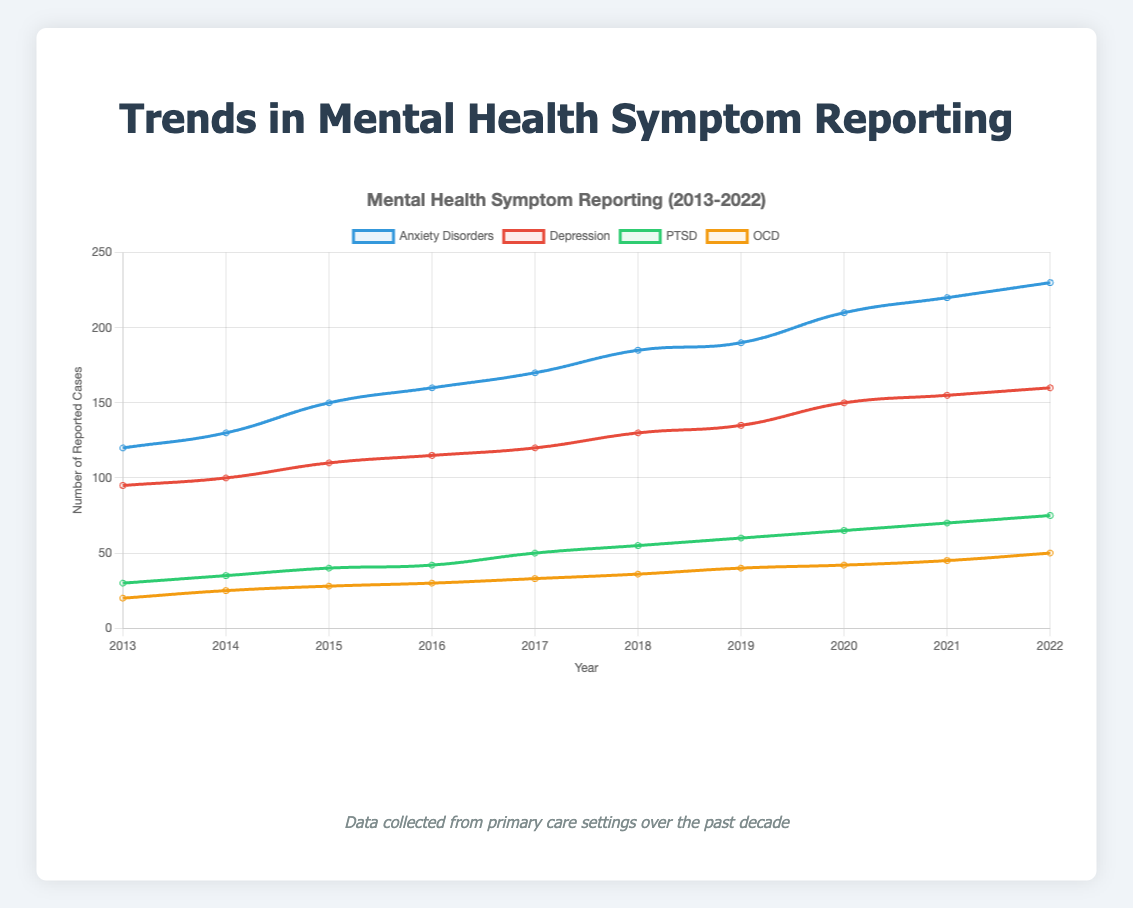How has the reporting trend for anxiety disorders changed over the decade? Observe the blue line representing anxiety disorders from 2013 to 2022. It starts at 120 in 2013 and gradually increases each year until it reaches 230 in 2022.
Answer: Increased steadily Which year saw the steepest increase in the number of depression cases reported? Look at the slope of the red line representing depression data points between consecutive years. The steepest increase occurs between 2019 and 2020, where it jumps from 135 to 150 cases.
Answer: 2019 to 2020 In 2020, what were the total reported cases for all mental health symptoms combined? Sum the reported cases for anxiety disorders, depression, PTSD, and OCD for the year 2020: 210 (anxiety) + 150 (depression) + 65 (PTSD) + 42 (OCD) = 467.
Answer: 467 Among the four symptoms tracked, which one had the least number of reported cases in 2021? Compare the data points for 2021: anxiety disorders (220), depression (155), PTSD (70), and OCD (45). OCD has the smallest number.
Answer: OCD By how much did the PTSD reporting increase from 2013 to 2022? Subtract the PTSD cases in 2013 from the cases in 2022: 75 (2022) - 30 (2013) = 45.
Answer: 45 Which mental health symptom had the greatest increase in reporting from 2013 to 2022? Calculate the increase for each symptom over this period: anxiety disorders (+110), depression (+65), PTSD (+45), OCD (+30). Anxiety disorders had the greatest increase.
Answer: Anxiety disorders How does the reporting trend for OCD compare to anxiety disorders in 2016? In 2016, OCD had 30 reported cases, while anxiety disorders had 160. Thus, anxiety disorders had a much higher reporting rate than OCD.
Answer: Anxiety disorders higher What was the average number of OCD cases reported annually from 2013 to 2022? Sum the OCD case numbers from 2013 to 2022 and divide by the number of years: (20+25+28+30+33+36+40+42+45+50)/10 = 349/10 = 34.9.
Answer: 34.9 Which symptom had the smallest increase in reporting from 2018 to 2020? Calculate the increase for each symptom from 2018 to 2020: anxiety disorders (+25), depression (+20), PTSD (+10), OCD (+6). OCD had the smallest increase.
Answer: OCD What percentage of the total reported cases in 2017 were depression cases? Find the total cases for 2017: 170 (anxiety) + 120 (depression) + 50 (PTSD) + 33 (OCD) = 373. Calculate the percentage: (120/373) * 100 ≈ 32.2%.
Answer: 32.2% 